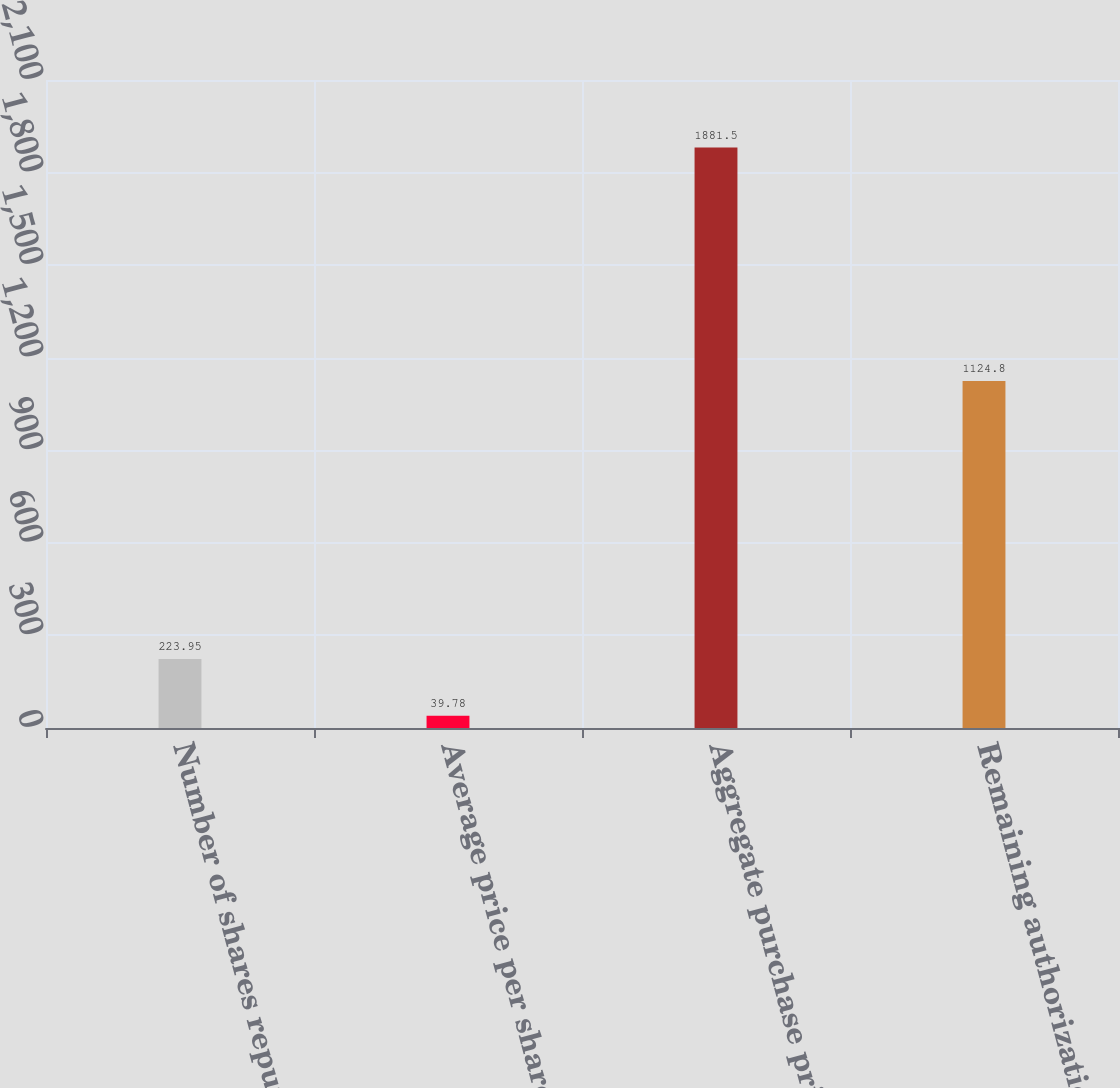Convert chart to OTSL. <chart><loc_0><loc_0><loc_500><loc_500><bar_chart><fcel>Number of shares repurchased<fcel>Average price per share<fcel>Aggregate purchase price<fcel>Remaining authorization at end<nl><fcel>223.95<fcel>39.78<fcel>1881.5<fcel>1124.8<nl></chart> 